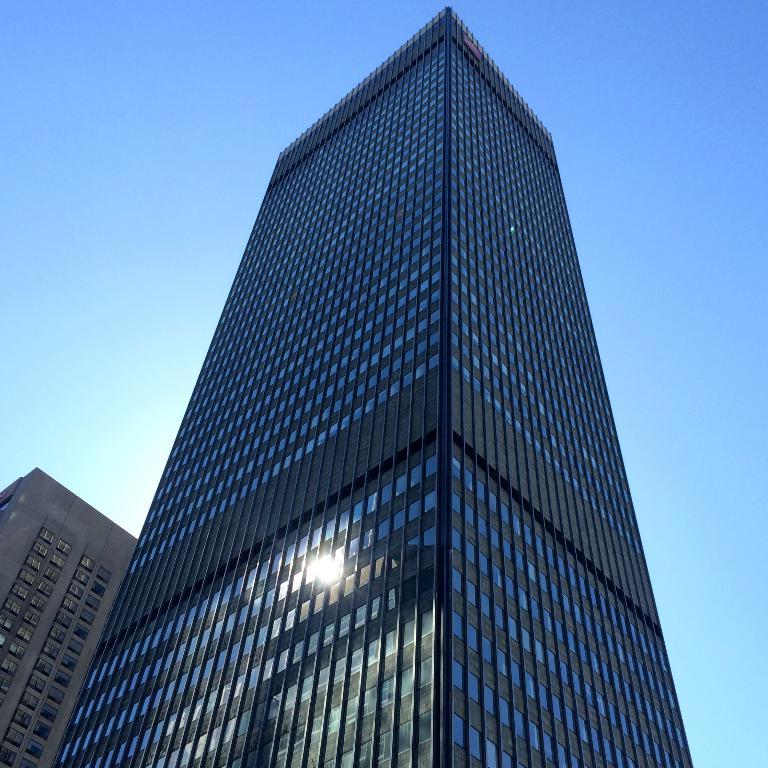What type of structures are present in the image? There are buildings in the image. What feature can be observed in the buildings? The buildings have glass doors. What is visible in the background of the image? The sky is visible in the background of the image. What type of lamp is present on the edge of the building in the image? There is no lamp present on the edge of the building in the image. How does friction affect the movement of the buildings in the image? The buildings in the image are stationary structures and do not move, so friction does not affect their movement. 